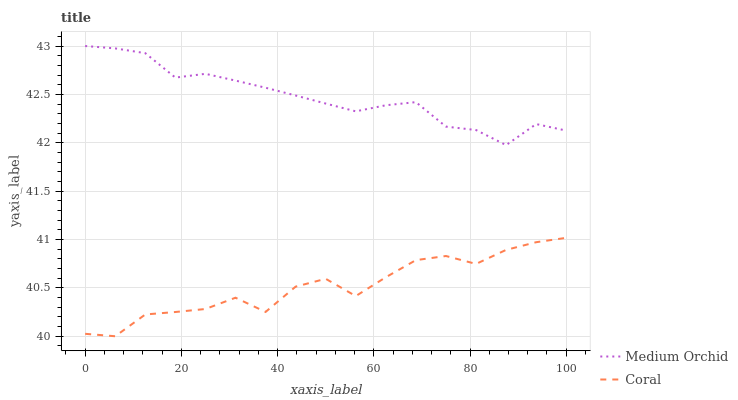Does Coral have the minimum area under the curve?
Answer yes or no. Yes. Does Medium Orchid have the maximum area under the curve?
Answer yes or no. Yes. Does Medium Orchid have the minimum area under the curve?
Answer yes or no. No. Is Medium Orchid the smoothest?
Answer yes or no. Yes. Is Coral the roughest?
Answer yes or no. Yes. Is Medium Orchid the roughest?
Answer yes or no. No. Does Medium Orchid have the lowest value?
Answer yes or no. No. Is Coral less than Medium Orchid?
Answer yes or no. Yes. Is Medium Orchid greater than Coral?
Answer yes or no. Yes. Does Coral intersect Medium Orchid?
Answer yes or no. No. 